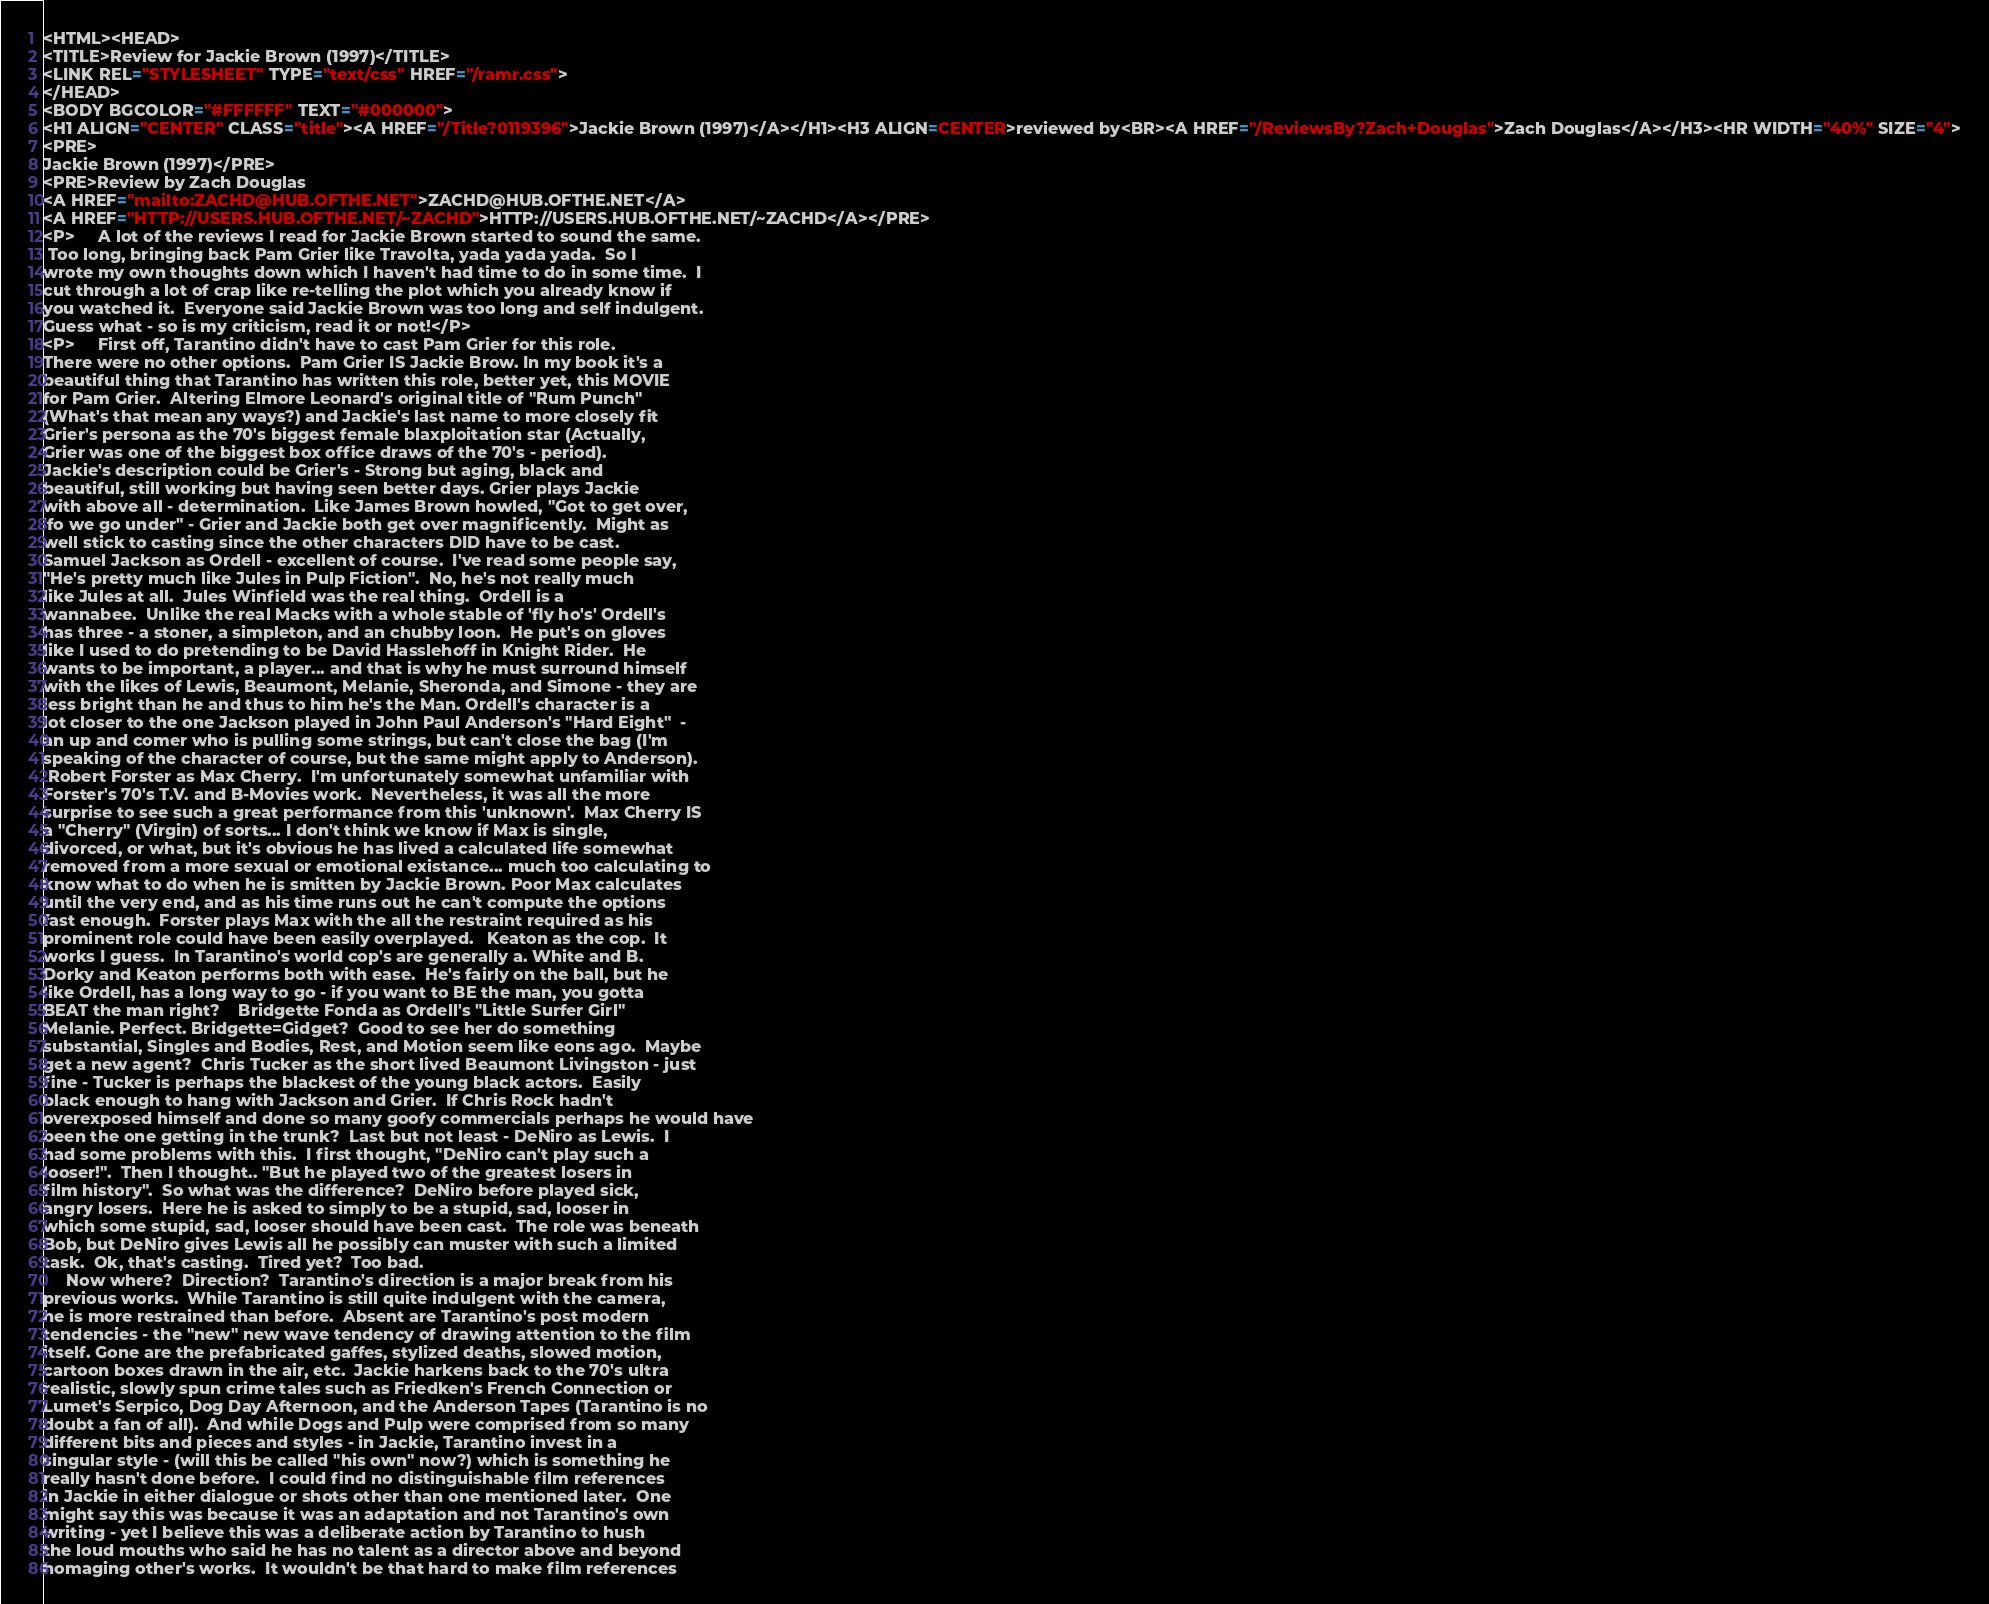<code> <loc_0><loc_0><loc_500><loc_500><_HTML_><HTML><HEAD>
<TITLE>Review for Jackie Brown (1997)</TITLE>
<LINK REL="STYLESHEET" TYPE="text/css" HREF="/ramr.css">
</HEAD>
<BODY BGCOLOR="#FFFFFF" TEXT="#000000">
<H1 ALIGN="CENTER" CLASS="title"><A HREF="/Title?0119396">Jackie Brown (1997)</A></H1><H3 ALIGN=CENTER>reviewed by<BR><A HREF="/ReviewsBy?Zach+Douglas">Zach Douglas</A></H3><HR WIDTH="40%" SIZE="4">
<PRE>
Jackie Brown (1997)</PRE>
<PRE>Review by Zach Douglas
<A HREF="mailto:ZACHD@HUB.OFTHE.NET">ZACHD@HUB.OFTHE.NET</A>
<A HREF="HTTP://USERS.HUB.OFTHE.NET/~ZACHD">HTTP://USERS.HUB.OFTHE.NET/~ZACHD</A></PRE>
<P>     A lot of the reviews I read for Jackie Brown started to sound the same. 
 Too long, bringing back Pam Grier like Travolta, yada yada yada.  So I 
wrote my own thoughts down which I haven't had time to do in some time.  I 
cut through a lot of crap like re-telling the plot which you already know if 
you watched it.  Everyone said Jackie Brown was too long and self indulgent. 
Guess what - so is my criticism, read it or not!</P>
<P>     First off, Tarantino didn't have to cast Pam Grier for this role.  
There were no other options.  Pam Grier IS Jackie Brow. In my book it's a 
beautiful thing that Tarantino has written this role, better yet, this MOVIE 
for Pam Grier.  Altering Elmore Leonard's original title of "Rum Punch" 
(What's that mean any ways?) and Jackie's last name to more closely fit 
Grier's persona as the 70's biggest female blaxploitation star (Actually, 
Grier was one of the biggest box office draws of the 70's - period).  
Jackie's description could be Grier's - Strong but aging, black and 
beautiful, still working but having seen better days. Grier plays Jackie 
with above all - determination.  Like James Brown howled, "Got to get over, 
'fo we go under" - Grier and Jackie both get over magnificently.  Might as 
well stick to casting since the other characters DID have to be cast.  
Samuel Jackson as Ordell - excellent of course.  I've read some people say, 
"He's pretty much like Jules in Pulp Fiction".  No, he's not really much 
like Jules at all.  Jules Winfield was the real thing.  Ordell is a 
wannabee.  Unlike the real Macks with a whole stable of 'fly ho's' Ordell's 
has three - a stoner, a simpleton, and an chubby loon.  He put's on gloves 
like I used to do pretending to be David Hasslehoff in Knight Rider.  He 
wants to be important, a player... and that is why he must surround himself 
with the likes of Lewis, Beaumont, Melanie, Sheronda, and Simone - they are 
less bright than he and thus to him he's the Man. Ordell's character is a 
lot closer to the one Jackson played in John Paul Anderson's "Hard Eight"  - 
an up and comer who is pulling some strings, but can't close the bag (I'm 
speaking of the character of course, but the same might apply to Anderson). 
 Robert Forster as Max Cherry.  I'm unfortunately somewhat unfamiliar with 
Forster's 70's T.V. and B-Movies work.  Nevertheless, it was all the more 
surprise to see such a great performance from this 'unknown'.  Max Cherry IS 
a "Cherry" (Virgin) of sorts... I don't think we know if Max is single, 
divorced, or what, but it's obvious he has lived a calculated life somewhat 
removed from a more sexual or emotional existance... much too calculating to 
know what to do when he is smitten by Jackie Brown. Poor Max calculates 
until the very end, and as his time runs out he can't compute the options 
fast enough.  Forster plays Max with the all the restraint required as his 
prominent role could have been easily overplayed.   Keaton as the cop.  It 
works I guess.  In Tarantino's world cop's are generally a. White and B. 
Dorky and Keaton performs both with ease.  He's fairly on the ball, but he 
like Ordell, has a long way to go - if you want to BE the man, you gotta 
BEAT the man right?    Bridgette Fonda as Ordell's "Little Surfer Girl" 
Melanie. Perfect. Bridgette=Gidget?  Good to see her do something 
substantial, Singles and Bodies, Rest, and Motion seem like eons ago.  Maybe 
get a new agent?  Chris Tucker as the short lived Beaumont Livingston - just 
fine - Tucker is perhaps the blackest of the young black actors.  Easily 
black enough to hang with Jackson and Grier.  If Chris Rock hadn't 
overexposed himself and done so many goofy commercials perhaps he would have 
been the one getting in the trunk?  Last but not least - DeNiro as Lewis.  I 
had some problems with this.  I first thought, "DeNiro can't play such a 
looser!".  Then I thought.. "But he played two of the greatest losers in 
film history".  So what was the difference?  DeNiro before played sick, 
angry losers.  Here he is asked to simply to be a stupid, sad, looser in 
which some stupid, sad, looser should have been cast.  The role was beneath 
Bob, but DeNiro gives Lewis all he possibly can muster with such a limited 
task.  Ok, that's casting.  Tired yet?  Too bad.
     Now where?  Direction?  Tarantino's direction is a major break from his 
previous works.  While Tarantino is still quite indulgent with the camera, 
he is more restrained than before.  Absent are Tarantino's post modern 
tendencies - the "new" new wave tendency of drawing attention to the film 
itself. Gone are the prefabricated gaffes, stylized deaths, slowed motion, 
cartoon boxes drawn in the air, etc.  Jackie harkens back to the 70's ultra 
realistic, slowly spun crime tales such as Friedken's French Connection or 
Lumet's Serpico, Dog Day Afternoon, and the Anderson Tapes (Tarantino is no 
doubt a fan of all).  And while Dogs and Pulp were comprised from so many 
different bits and pieces and styles - in Jackie, Tarantino invest in a
singular style - (will this be called "his own" now?) which is something he 
really hasn't done before.  I could find no distinguishable film references 
in Jackie in either dialogue or shots other than one mentioned later.  One 
might say this was because it was an adaptation and not Tarantino's own 
writing - yet I believe this was a deliberate action by Tarantino to hush 
the loud mouths who said he has no talent as a director above and beyond 
homaging other's works.  It wouldn't be that hard to make film references </code> 